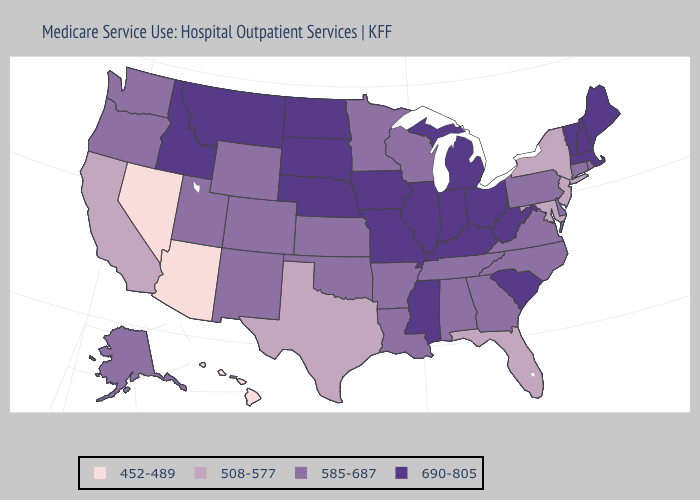What is the lowest value in states that border Pennsylvania?
Quick response, please. 508-577. Does Florida have a lower value than Oregon?
Give a very brief answer. Yes. Name the states that have a value in the range 690-805?
Answer briefly. Idaho, Illinois, Indiana, Iowa, Kentucky, Maine, Massachusetts, Michigan, Mississippi, Missouri, Montana, Nebraska, New Hampshire, North Dakota, Ohio, South Carolina, South Dakota, Vermont, West Virginia. Among the states that border New Hampshire , which have the lowest value?
Quick response, please. Maine, Massachusetts, Vermont. Name the states that have a value in the range 585-687?
Write a very short answer. Alabama, Alaska, Arkansas, Colorado, Connecticut, Delaware, Georgia, Kansas, Louisiana, Minnesota, New Mexico, North Carolina, Oklahoma, Oregon, Pennsylvania, Rhode Island, Tennessee, Utah, Virginia, Washington, Wisconsin, Wyoming. Name the states that have a value in the range 690-805?
Short answer required. Idaho, Illinois, Indiana, Iowa, Kentucky, Maine, Massachusetts, Michigan, Mississippi, Missouri, Montana, Nebraska, New Hampshire, North Dakota, Ohio, South Carolina, South Dakota, Vermont, West Virginia. Which states have the lowest value in the USA?
Write a very short answer. Arizona, Hawaii, Nevada. What is the lowest value in the USA?
Give a very brief answer. 452-489. Name the states that have a value in the range 585-687?
Keep it brief. Alabama, Alaska, Arkansas, Colorado, Connecticut, Delaware, Georgia, Kansas, Louisiana, Minnesota, New Mexico, North Carolina, Oklahoma, Oregon, Pennsylvania, Rhode Island, Tennessee, Utah, Virginia, Washington, Wisconsin, Wyoming. Name the states that have a value in the range 690-805?
Give a very brief answer. Idaho, Illinois, Indiana, Iowa, Kentucky, Maine, Massachusetts, Michigan, Mississippi, Missouri, Montana, Nebraska, New Hampshire, North Dakota, Ohio, South Carolina, South Dakota, Vermont, West Virginia. Does the map have missing data?
Quick response, please. No. What is the highest value in states that border Georgia?
Keep it brief. 690-805. Does North Carolina have a lower value than Georgia?
Concise answer only. No. Does the map have missing data?
Answer briefly. No. Which states have the highest value in the USA?
Write a very short answer. Idaho, Illinois, Indiana, Iowa, Kentucky, Maine, Massachusetts, Michigan, Mississippi, Missouri, Montana, Nebraska, New Hampshire, North Dakota, Ohio, South Carolina, South Dakota, Vermont, West Virginia. 